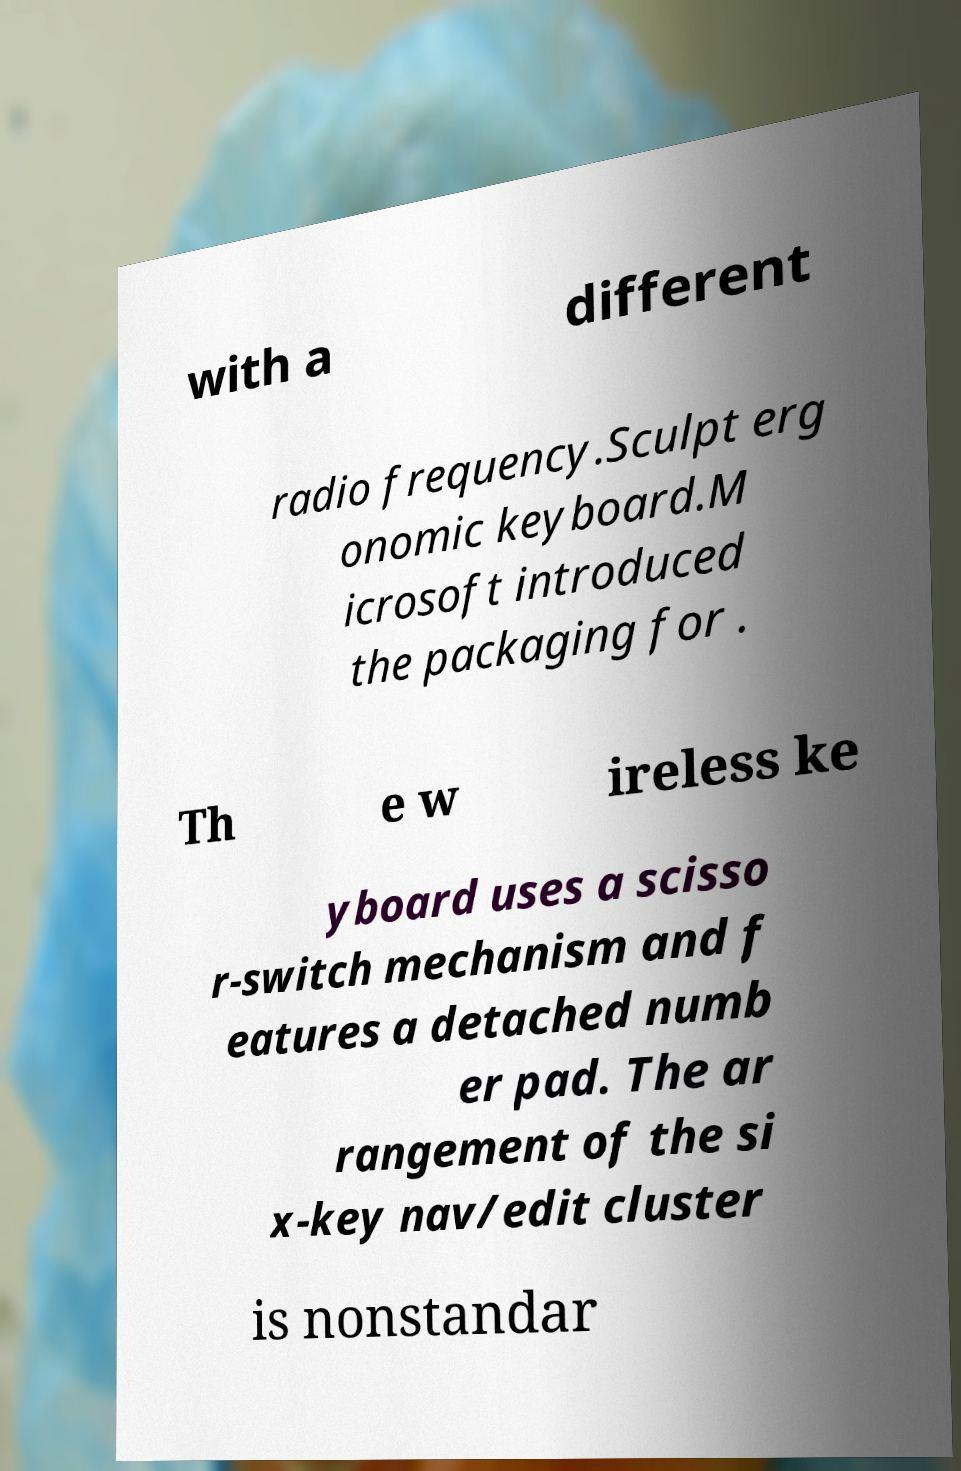Could you assist in decoding the text presented in this image and type it out clearly? with a different radio frequency.Sculpt erg onomic keyboard.M icrosoft introduced the packaging for . Th e w ireless ke yboard uses a scisso r-switch mechanism and f eatures a detached numb er pad. The ar rangement of the si x-key nav/edit cluster is nonstandar 